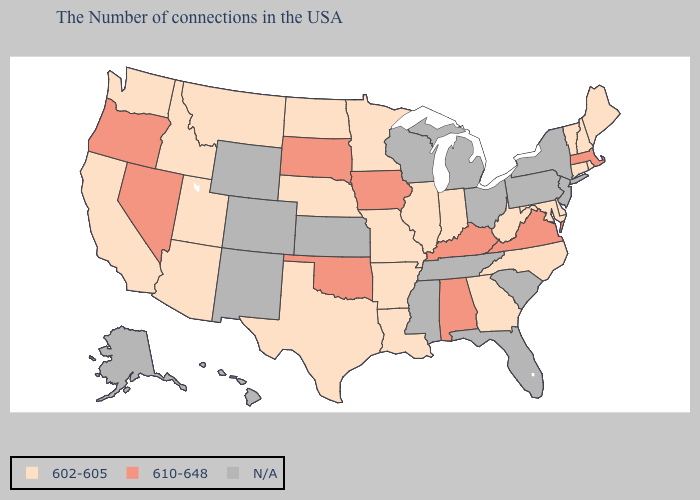Which states have the lowest value in the USA?
Keep it brief. Maine, Rhode Island, New Hampshire, Vermont, Connecticut, Delaware, Maryland, North Carolina, West Virginia, Georgia, Indiana, Illinois, Louisiana, Missouri, Arkansas, Minnesota, Nebraska, Texas, North Dakota, Utah, Montana, Arizona, Idaho, California, Washington. Name the states that have a value in the range 602-605?
Quick response, please. Maine, Rhode Island, New Hampshire, Vermont, Connecticut, Delaware, Maryland, North Carolina, West Virginia, Georgia, Indiana, Illinois, Louisiana, Missouri, Arkansas, Minnesota, Nebraska, Texas, North Dakota, Utah, Montana, Arizona, Idaho, California, Washington. Is the legend a continuous bar?
Write a very short answer. No. What is the value of Texas?
Give a very brief answer. 602-605. What is the value of Florida?
Write a very short answer. N/A. Name the states that have a value in the range 602-605?
Short answer required. Maine, Rhode Island, New Hampshire, Vermont, Connecticut, Delaware, Maryland, North Carolina, West Virginia, Georgia, Indiana, Illinois, Louisiana, Missouri, Arkansas, Minnesota, Nebraska, Texas, North Dakota, Utah, Montana, Arizona, Idaho, California, Washington. Which states hav the highest value in the South?
Write a very short answer. Virginia, Kentucky, Alabama, Oklahoma. What is the value of North Dakota?
Write a very short answer. 602-605. Is the legend a continuous bar?
Quick response, please. No. What is the lowest value in the USA?
Short answer required. 602-605. What is the value of Maine?
Be succinct. 602-605. Does Massachusetts have the lowest value in the Northeast?
Short answer required. No. Which states have the lowest value in the USA?
Write a very short answer. Maine, Rhode Island, New Hampshire, Vermont, Connecticut, Delaware, Maryland, North Carolina, West Virginia, Georgia, Indiana, Illinois, Louisiana, Missouri, Arkansas, Minnesota, Nebraska, Texas, North Dakota, Utah, Montana, Arizona, Idaho, California, Washington. 